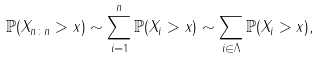Convert formula to latex. <formula><loc_0><loc_0><loc_500><loc_500>\mathbb { P } ( X _ { n \colon n } > x ) \sim \sum _ { i = 1 } ^ { n } \mathbb { P } ( X _ { i } > x ) \sim \sum _ { i \in \Lambda } \mathbb { P } ( X _ { i } > x ) ,</formula> 